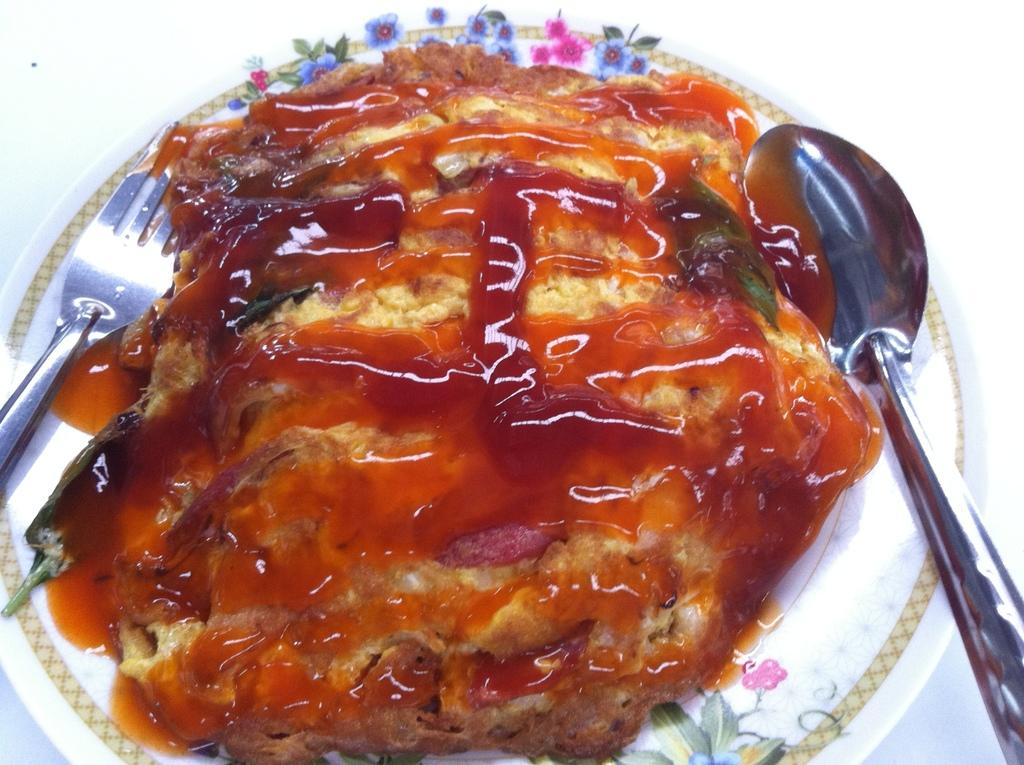What type of food item can be seen in the image? There is a food item in the image, and it has jam on it. What utensils are present in the image? There is a spoon and a fork in the image. What color is the plate in the image? The plate is white in color. What color is the background in the image? The background is white in color. What type of quartz can be seen in the image? There is no quartz present in the image. How does the food item pull the spoon towards it in the image? The food item does not pull the spoon towards it in the image; the spoon is stationary. 